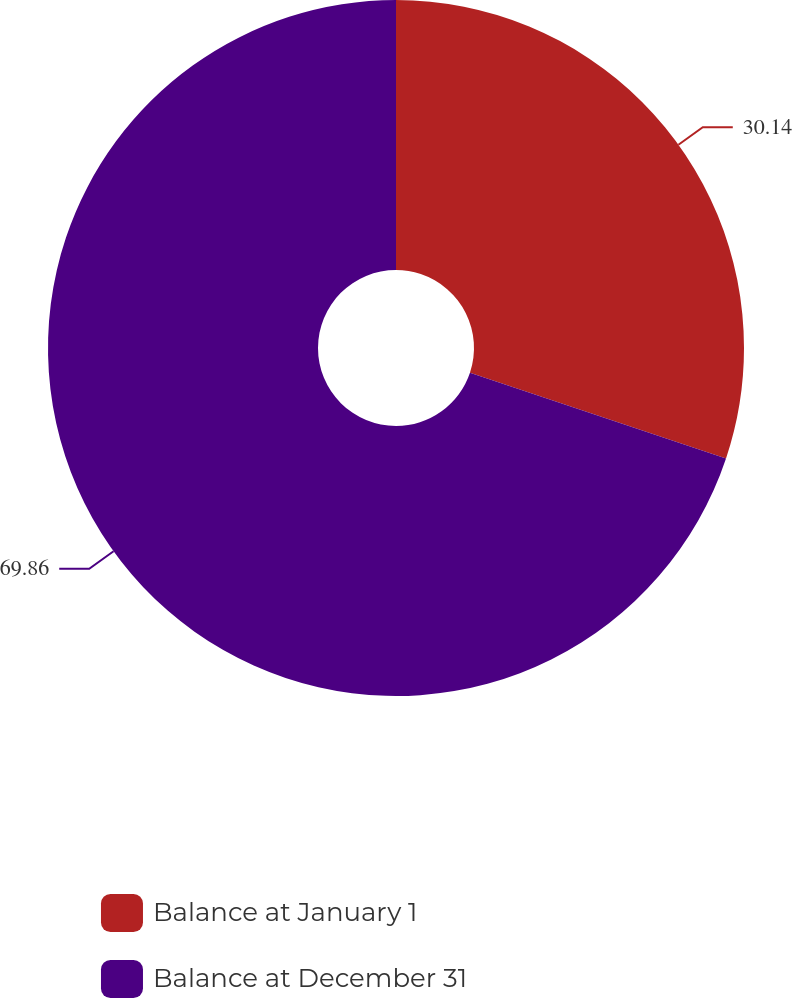Convert chart to OTSL. <chart><loc_0><loc_0><loc_500><loc_500><pie_chart><fcel>Balance at January 1<fcel>Balance at December 31<nl><fcel>30.14%<fcel>69.86%<nl></chart> 